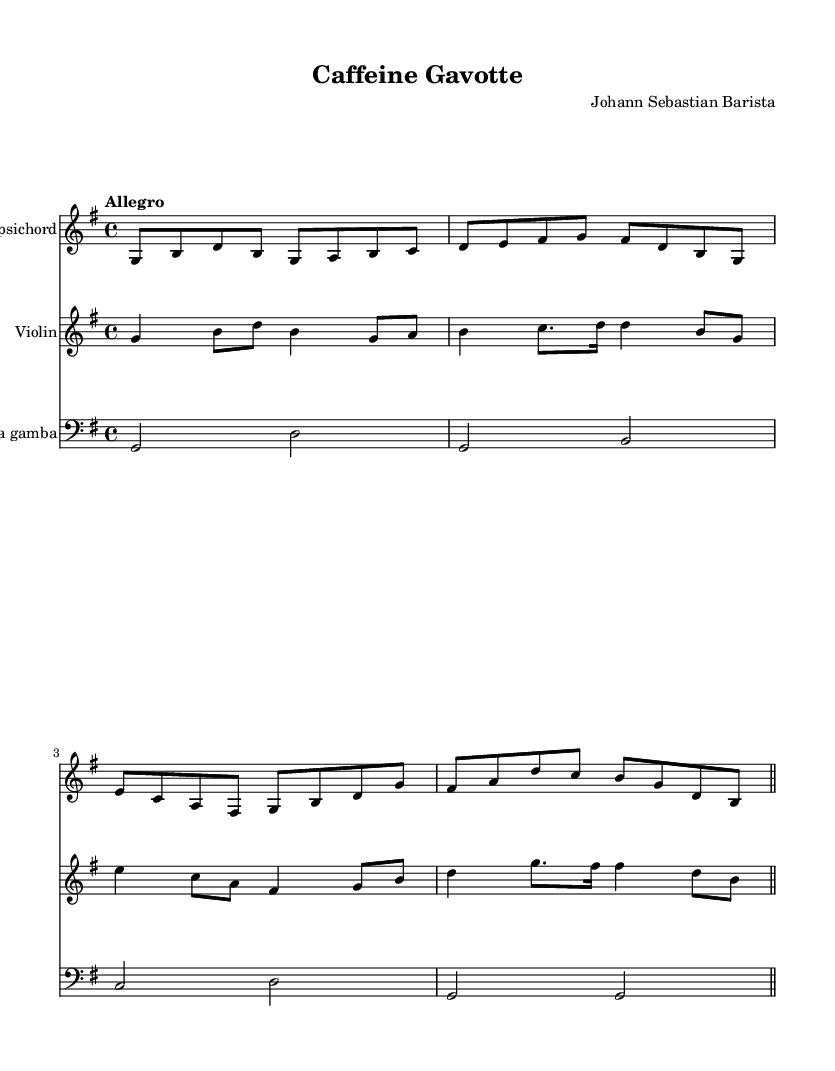What is the title of this music? The title is indicated at the top of the sheet music in the header section. It says "Caffeine Gavotte."
Answer: Caffeine Gavotte Who is the composer of this piece? The composer is listed in the header section of the sheet music, which names "Johann Sebastian Barista."
Answer: Johann Sebastian Barista What is the key signature of this music? The key is indicated at the beginning of the global section where it states "g \major," indicating there is one sharp (F#).
Answer: G major What is the time signature of this music? The time signature is found in the same global section and is specified as "4/4," meaning there are 4 beats in each measure.
Answer: 4/4 What is the tempo marking for this music? The tempo is marked as "Allegro" in the global section, which indicates a fast and lively pace.
Answer: Allegro How many measures are in the harpsichord part? The harpsichord part consists of the notes laid out in measures. Counting the measures, there are four total.
Answer: Four Which instrument plays the lowest pitch? The viola da gamba is the instrument that plays the lowest pitch as it is shown in the bass clef and its notes are lower than the harpsichord and violin.
Answer: Viola da gamba 